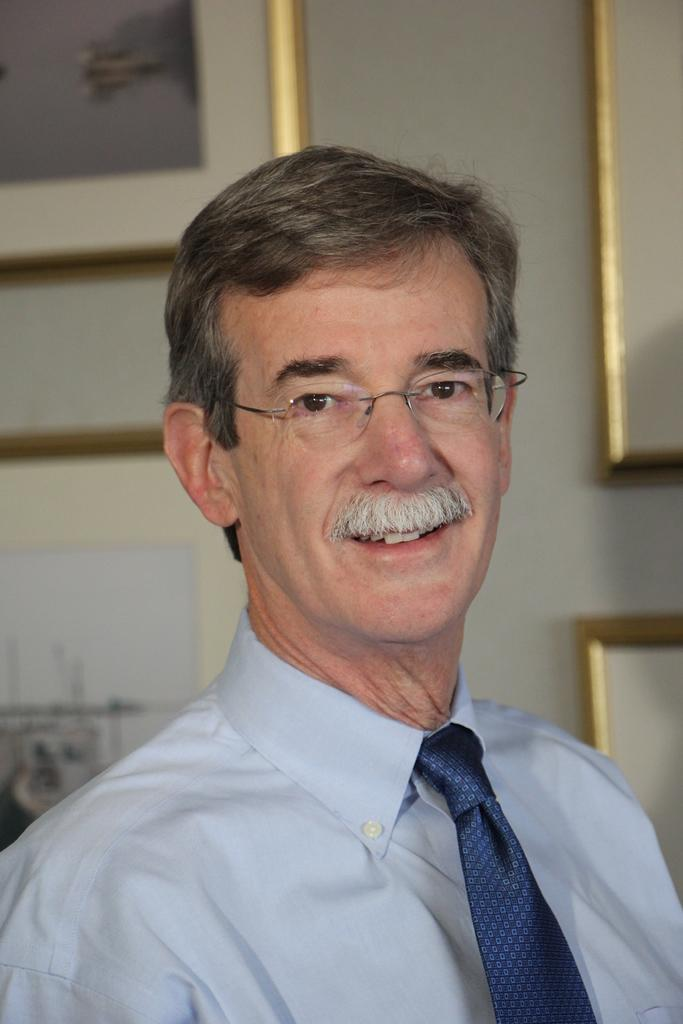Who is present in the image? There is a man in the image. What is the man's facial expression? The man is smiling. What accessories is the man wearing? The man is wearing spectacles and a tie. What can be seen in the background of the image? There are frames on a wall in the background of the image. How much value does the man's face have in the image? The value of the man's face cannot be determined in the image, as it is not a financial or numerical concept. 